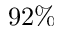<formula> <loc_0><loc_0><loc_500><loc_500>9 2 \%</formula> 